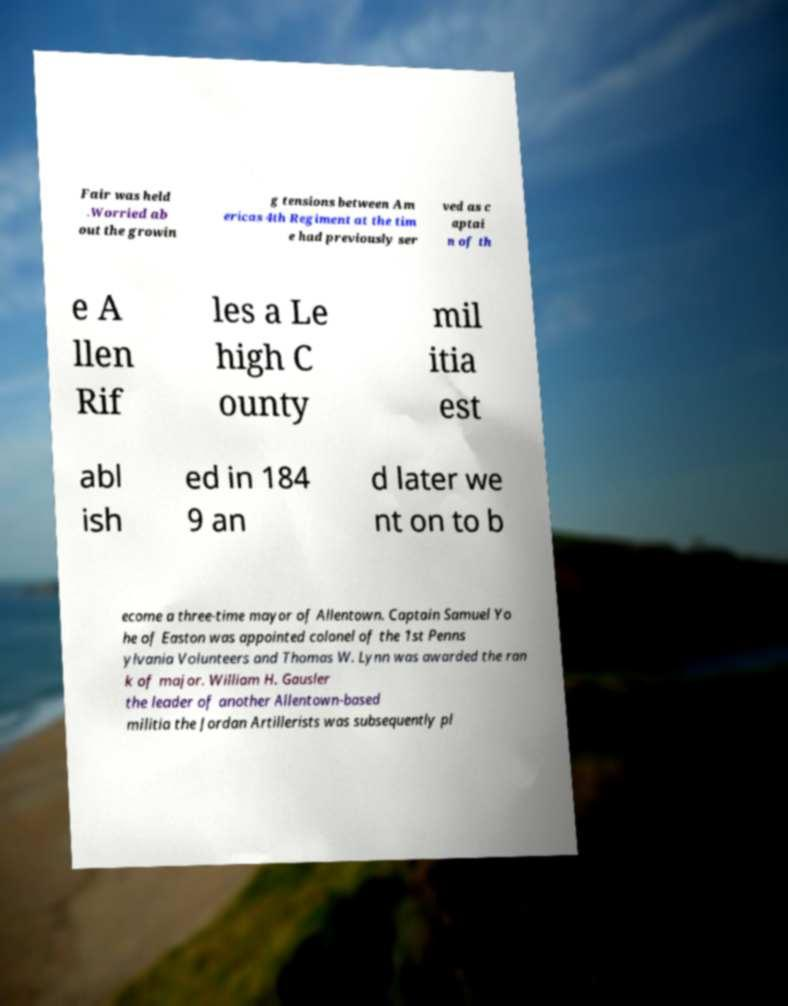I need the written content from this picture converted into text. Can you do that? Fair was held .Worried ab out the growin g tensions between Am ericas 4th Regiment at the tim e had previously ser ved as c aptai n of th e A llen Rif les a Le high C ounty mil itia est abl ish ed in 184 9 an d later we nt on to b ecome a three-time mayor of Allentown. Captain Samuel Yo he of Easton was appointed colonel of the 1st Penns ylvania Volunteers and Thomas W. Lynn was awarded the ran k of major. William H. Gausler the leader of another Allentown-based militia the Jordan Artillerists was subsequently pl 